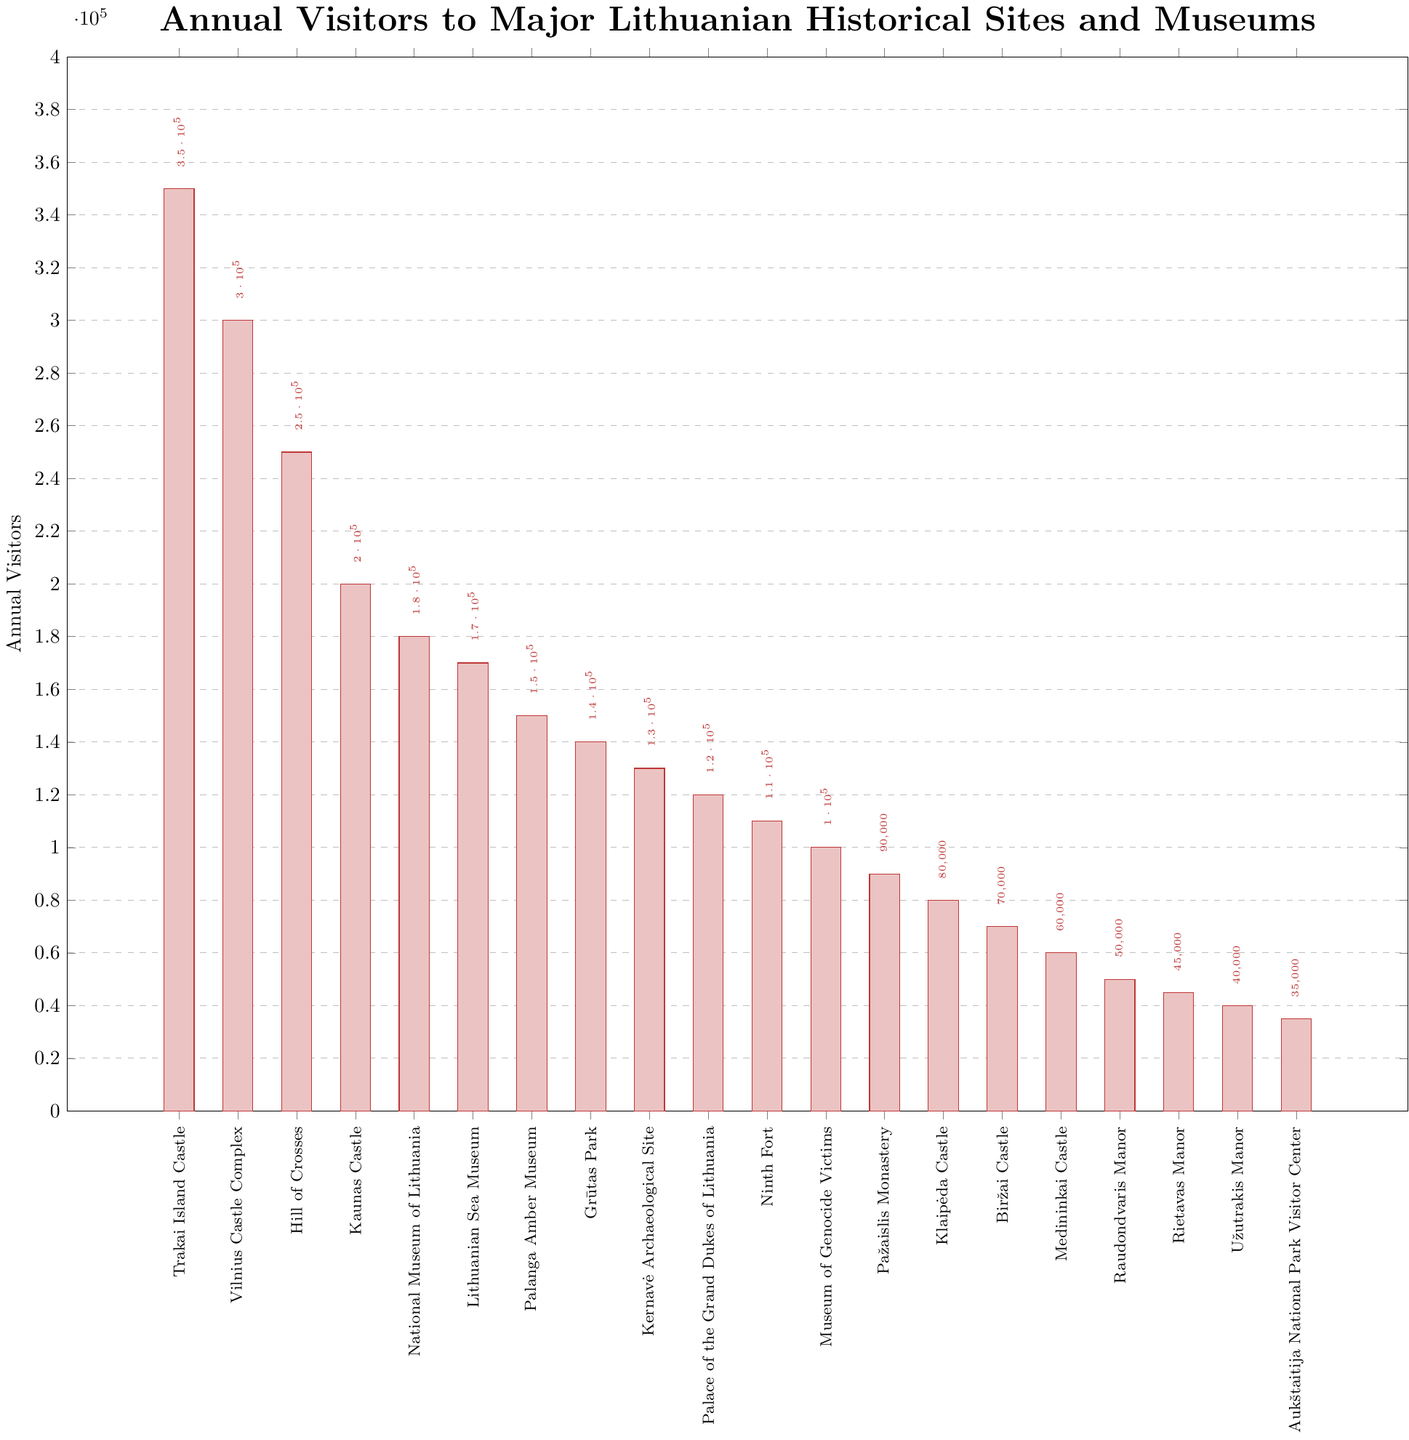Which site has the most annual visitors? By looking at the bar chart, the tallest bar indicates the site with the most annual visitors.
Answer: Trakai Island Castle How many more visitors does Trakai Island Castle have compared to the Ninth Fort? Subtract the number of annual visitors of Ninth Fort from that of Trakai Island Castle (350,000 - 110,000).
Answer: 240,000 Which site has the fewest annual visitors? The shortest bar on the chart represents the site with the fewest annual visitors.
Answer: Aukštaitija National Park Visitor Center What is the total number of visitors for the top three sites combined? Sum the number of annual visitors of Trakai Island Castle, Vilnius Castle Complex, and Hill of Crosses (350,000 + 300,000 + 250,000).
Answer: 900,000 Are there more visitors to the Lithuanian Sea Museum or the Kaunas Castle? Compare the height of the bars representing Lithuanian Sea Museum and Kaunas Castle.
Answer: Kaunas Castle What is the median number of visitors for all listed sites? Arrange the visitor numbers in ascending order and find the middle value (or the average of the two middle values if the number of data points is even).
Answer: 105,000 How does the number of visitors to the Museum of Genocide Victims compare to the Palace of the Grand Dukes of Lithuania? Simply compare the respective bar heights of these two institutions.
Answer: The Palace of the Grand Dukes of Lithuania has more visitors What is the difference in annual visitors between Raudondvaris Manor and Rietavas Manor? Subtract the number of annual visitors of Rietavas Manor from that of Raudondvaris Manor (50,000 - 45,000).
Answer: 5,000 What are the combined visitors for all the sites with fewer than 100,000 annual visitors? Sum the number of annual visitors for each site with less than 100,000 visitors: Museum of Genocide Victims, Pažaislis Monastery, Klaipėda Castle, Biržai Castle, Medininkai Castle, Raudondvaris Manor, Rietavas Manor, Užutrakis Manor, Aukštaitija National Park Visitor Center (100,000 + 90,000 + 80,000 + 70,000 + 60,000 + 50,000 + 45,000 + 40,000 + 35,000).
Answer: 570,000 